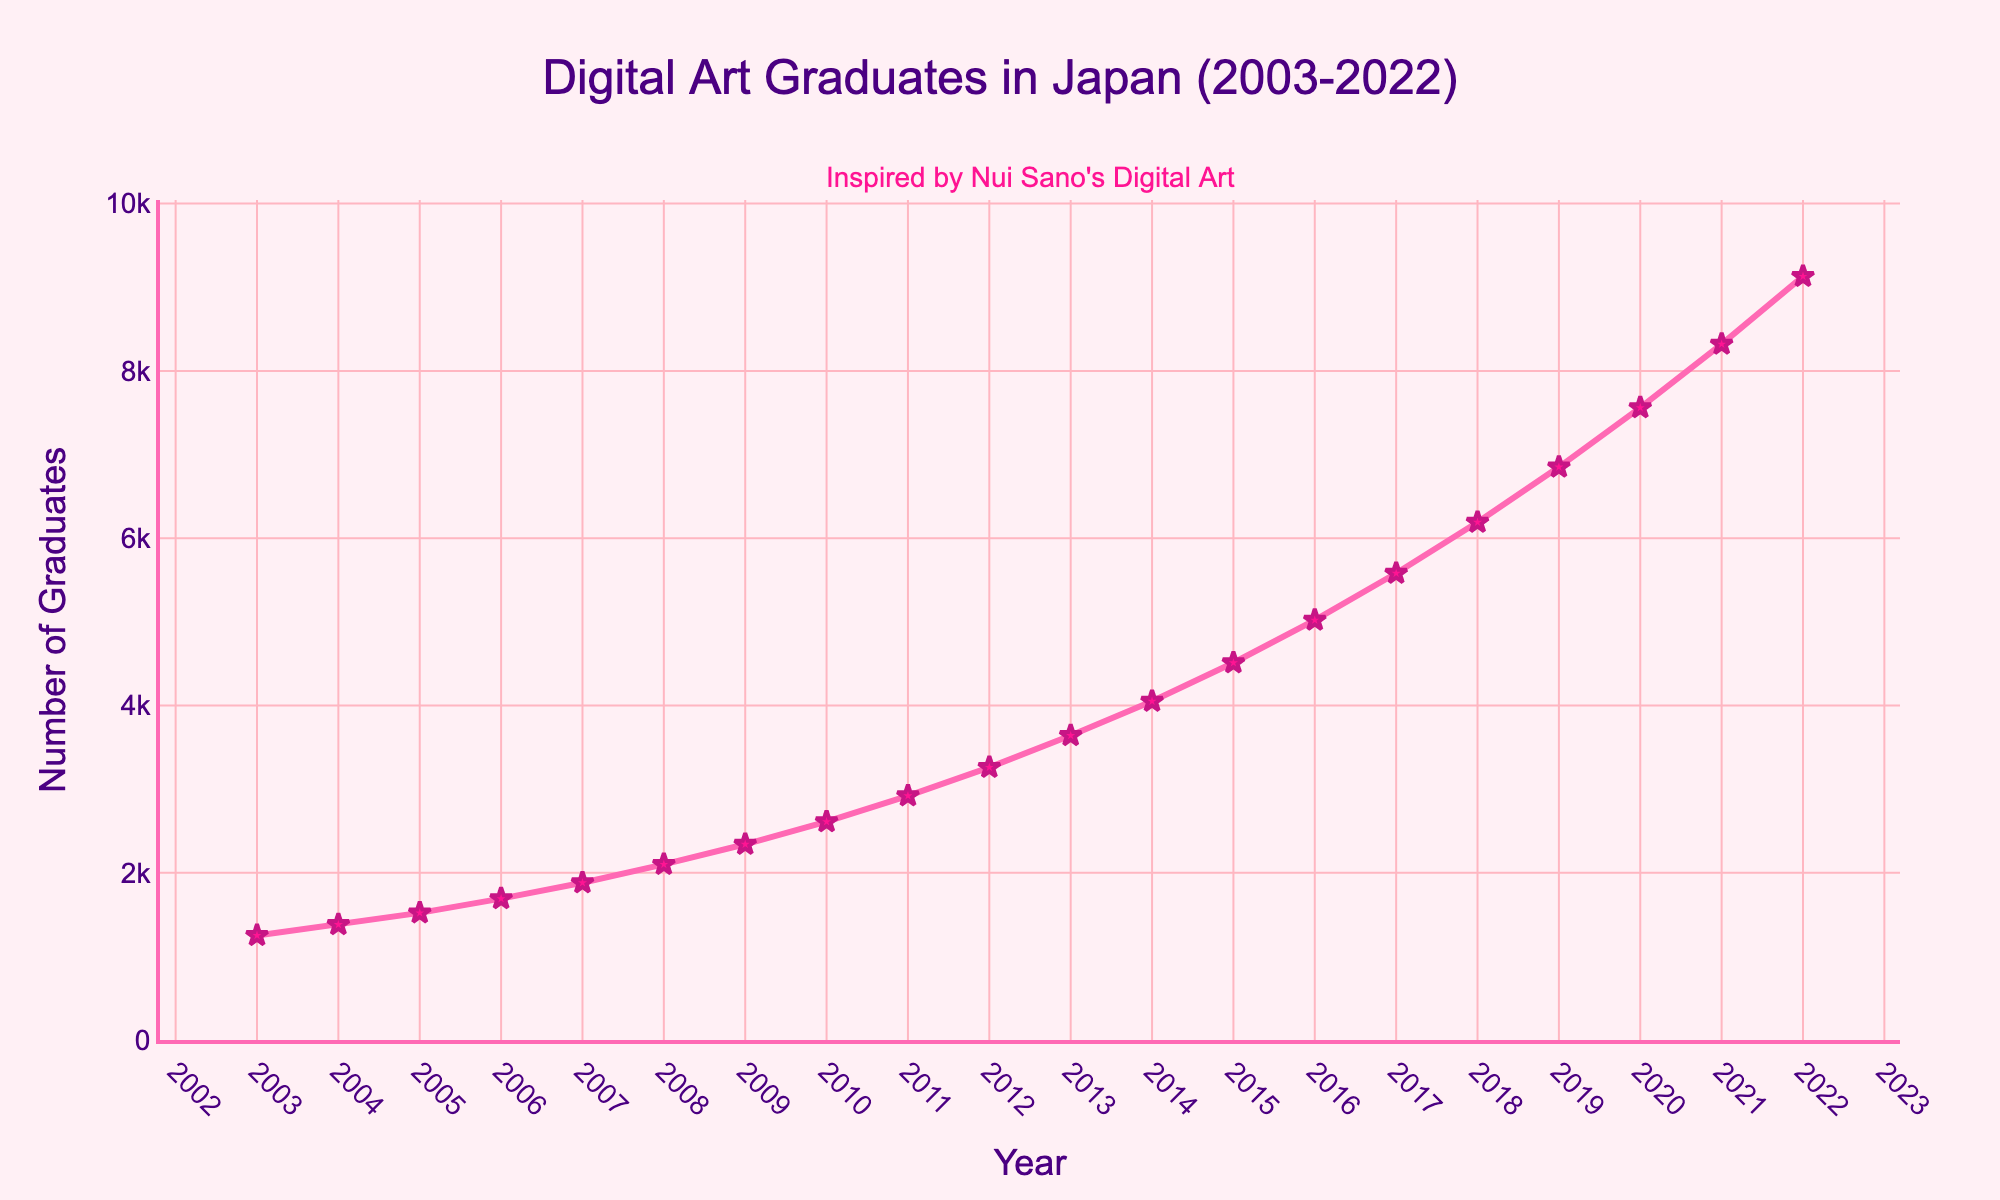Which year had the highest number of digital art graduates? By looking at the end of the line in the chart, we can see that the number of digital art graduates peaks in the year 2022.
Answer: 2022 What is the difference in the number of digital art graduates between 2003 and 2022? The number of graduates in 2003 is 1250 and in 2022 is 9130. Subtracting 1250 from 9130 gives 7880.
Answer: 7880 How many years did it take for the number of digital art graduates to double from 2003? The number of graduates in 2003 is 1250. Doubling this number we get 2500. Referring to the chart, the number of graduates exceeds 2500 in the year 2010. Counting the years from 2003 to 2010 gives 7 years.
Answer: 7 years In which year was there the largest increase in the number of digital art graduates compared to the previous year? By comparing all consecutive years, the largest increase occurs between 2021 (8320 graduates) and 2022 (9130 graduates), which is an increase of 810 graduates.
Answer: 2021 to 2022 How many digital art graduates were there in the middle year of the dataset? The data spans 20 years from 2003 to 2022. The middle year is 2012. Looking at the number of graduates in 2012, we find it is 3260.
Answer: 3260 By how much did the number of digital art graduates increase on average per year over the entire period? The total increase from 2003 to 2022 is 7880 graduates over 19 years. Dividing 7880 by 19 gives an average annual increase of about 415.8 graduates.
Answer: 415.8 graduates/year What is the trend in the number of digital art graduates from 2003 to 2022? Observing the line chart, there is a steady and consistent upward trend in the number of digital art graduates from 2003 to 2022.
Answer: Upward trend How does the number of digital art graduates in 2015 compare to that in 2010? In 2010, there were 2610 graduates, and in 2015, there were 4510 graduates. Comparing these numbers, 2015 had 1900 more graduates than 2010.
Answer: 1900 more in 2015 What visual elements indicate the importance of the data on the chart? The chart uses a bold pink line and star markers to highlight the data points for digital art graduates, and an annotation mentioning "Inspired by Nui Sano's Digital Art" adds context and emphasis.
Answer: Bold pink line, star markers, annotation 